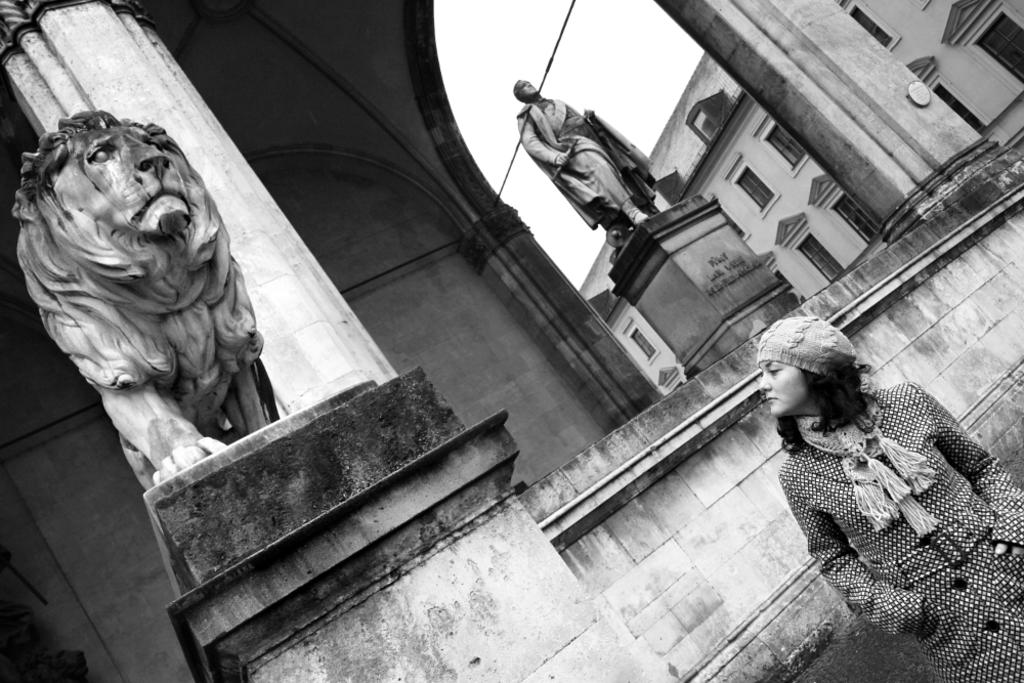What type of structures are present in the image? There are buildings in the image. What architectural feature can be seen on the buildings? There are windows visible on the buildings. What type of statues are present in the image? There is a human statue and a lion statue in the image. What is visible in the background of the image? The sky is visible in the image. What is the position of the woman in the image? The woman is standing on the right side of the image. What type of bell can be heard ringing in the image? There is no bell present in the image, and therefore no sound can be heard. What shape is the keyhole on the square statue in the image? There is no square statue present in the image, and therefore no keyhole can be observed. 